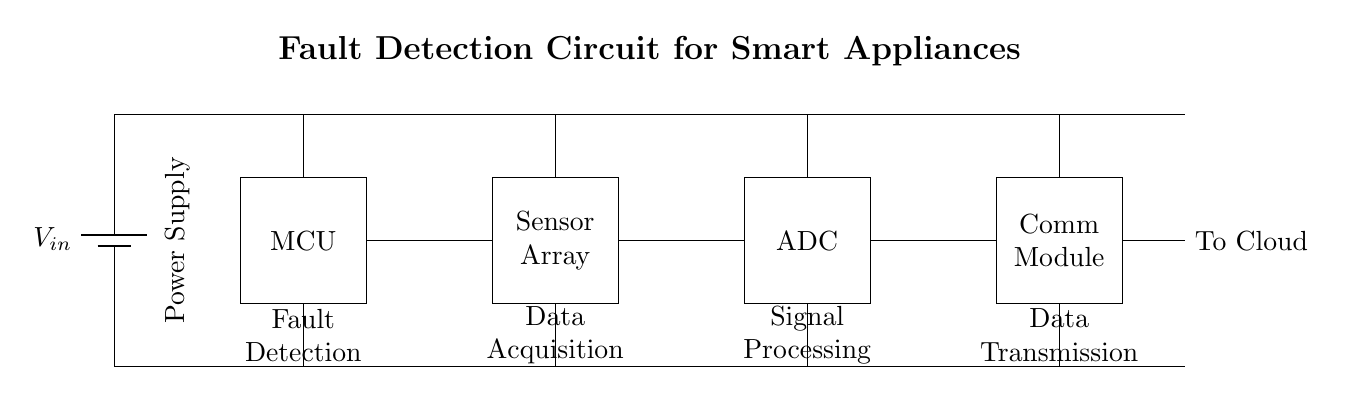What is the purpose of the circuit? The circuit is designed for fault detection, indicated by the label "Fault Detection" near the microcontroller. This suggests that it monitors the performance of smart appliances to identify potential issues.
Answer: Fault detection What are the components of this circuit? The circuit consists of a power supply, a microcontroller (MCU), a sensor array, an analog-to-digital converter (ADC), and a communication module. Each component is clearly labeled in the diagram.
Answer: Power supply, MCU, sensor array, ADC, communication module How many main functional units are in the circuit? The circuit has four main functional units: fault detection, data acquisition, signal processing, and data transmission, as indicated by the labels beneath each component.
Answer: Four What is the flow of information in the circuit from the MCU? The flow starts from the MCU, connecting to the sensor array for data acquisition, followed by the ADC for signal processing, and finally to the communication module for data transmission to the cloud.
Answer: MCU to sensor array to ADC to communication module What is the role of the ADC in this circuit? The ADC (analog-to-digital converter) is responsible for converting the analog signals received from the sensor array into digital signals that can be processed by the microcontroller. This is critical for effective fault detection.
Answer: Signal conversion Where does the power supply connect in the circuit? The power supply connects vertically at the left side and supplies power to all components, with individual connections leading to each functional unit indicated by the upward lines.
Answer: Left side What type of data is sent to the cloud? The data transmitted to the cloud is processed data from the signal processing unit, which is likely fault-related information derived from the sensors and processed through the ADC.
Answer: Fault-related data 